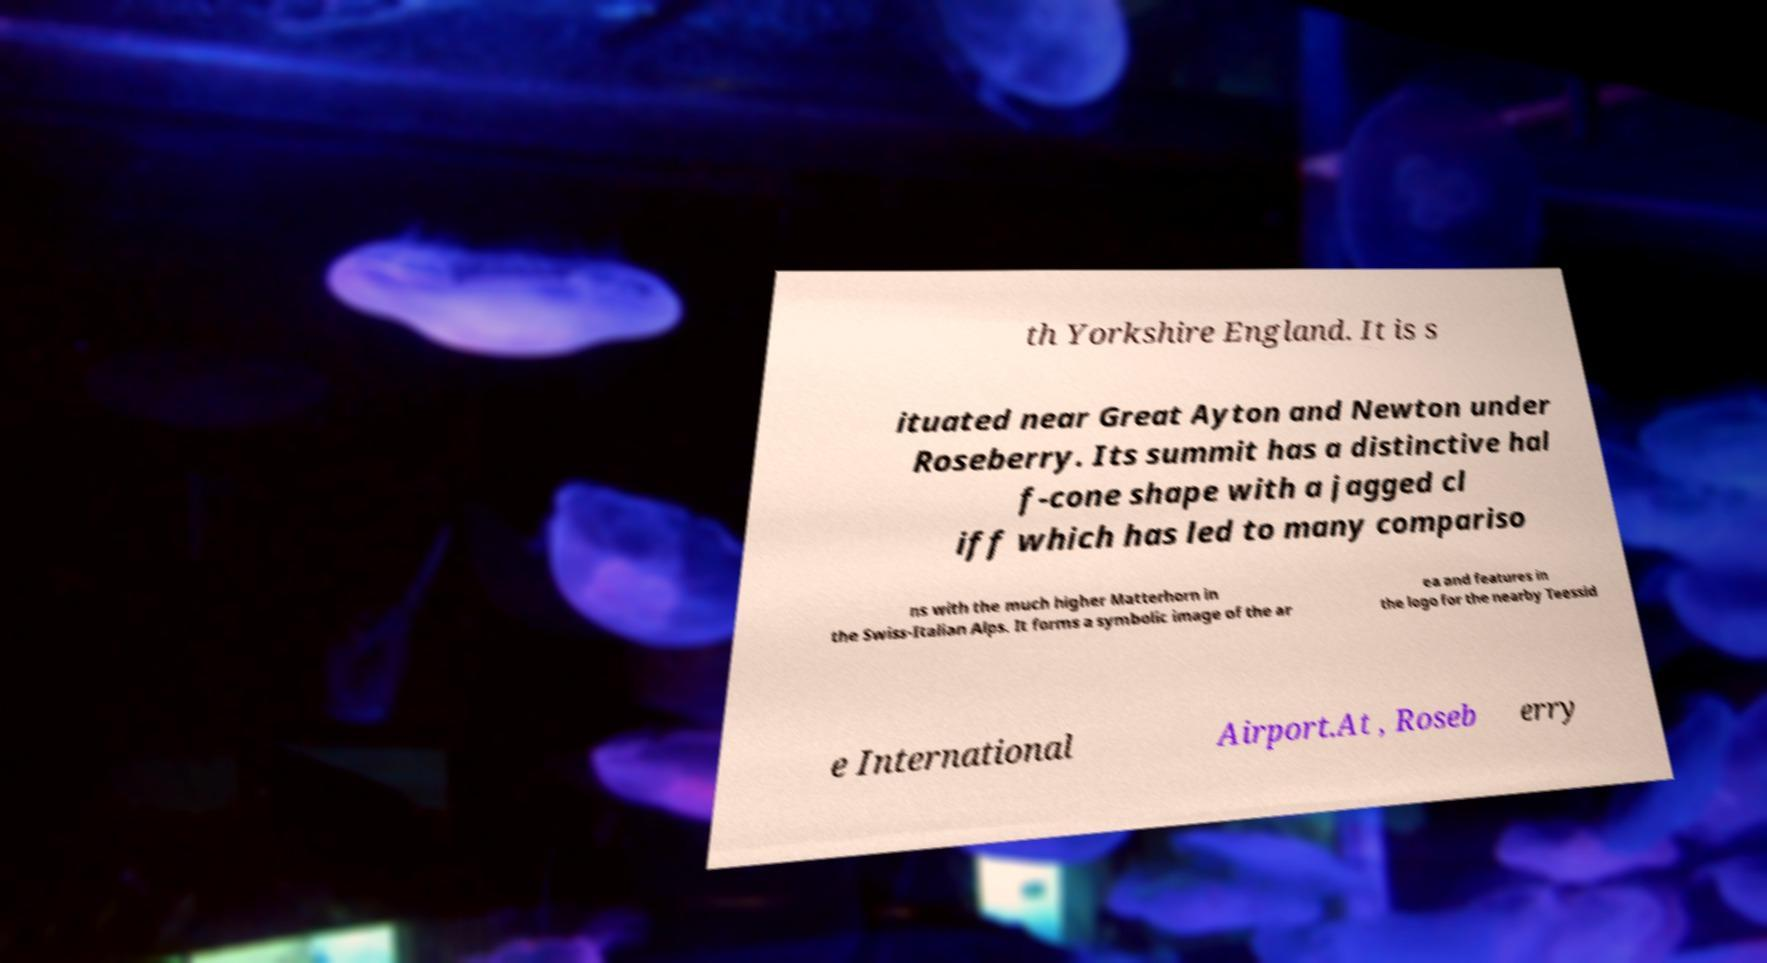Can you accurately transcribe the text from the provided image for me? th Yorkshire England. It is s ituated near Great Ayton and Newton under Roseberry. Its summit has a distinctive hal f-cone shape with a jagged cl iff which has led to many compariso ns with the much higher Matterhorn in the Swiss-Italian Alps. It forms a symbolic image of the ar ea and features in the logo for the nearby Teessid e International Airport.At , Roseb erry 